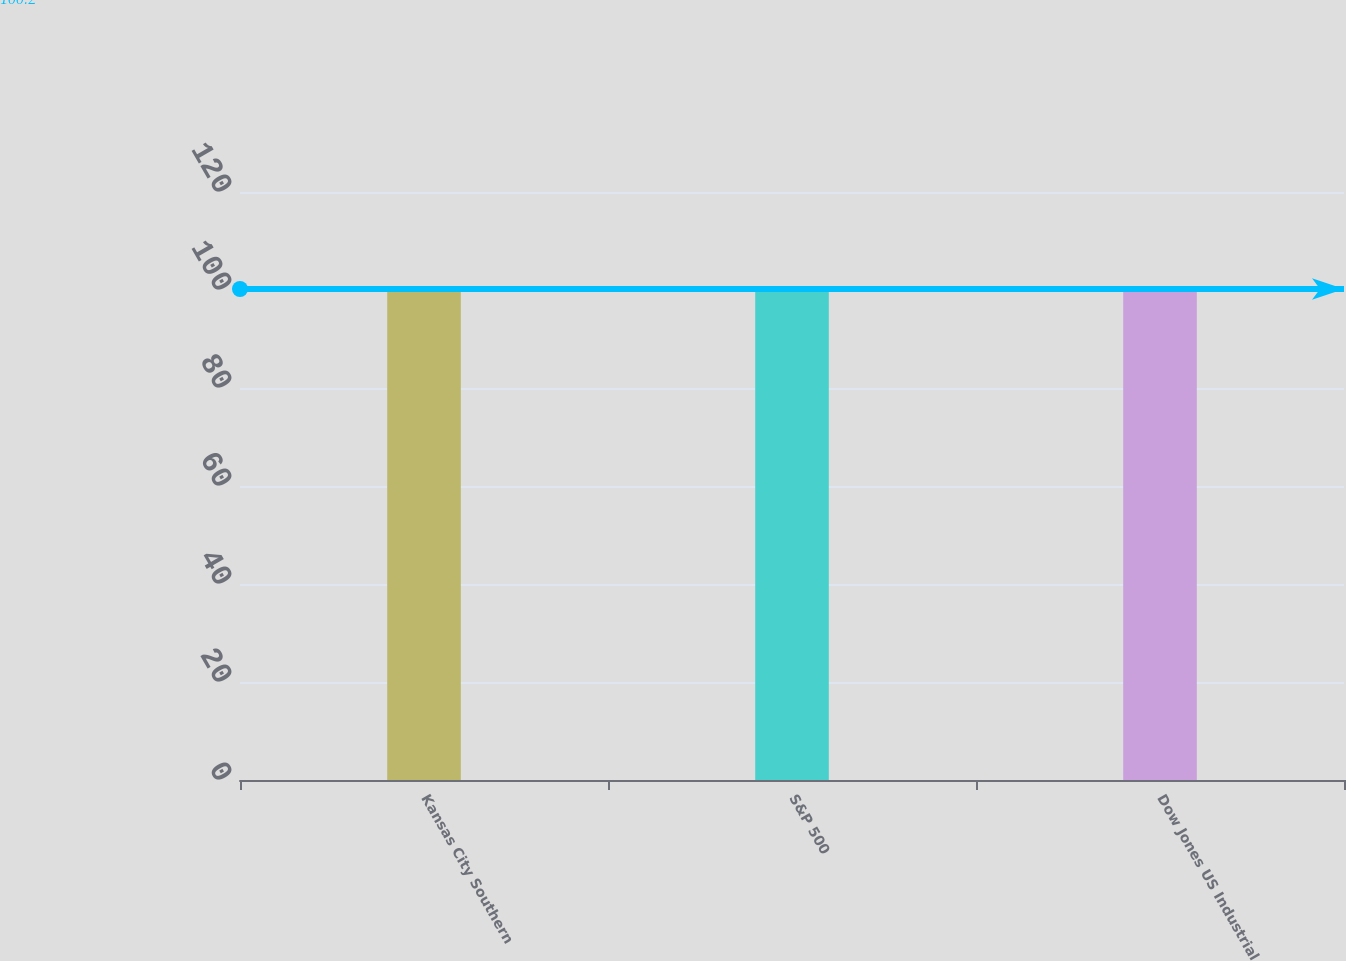Convert chart. <chart><loc_0><loc_0><loc_500><loc_500><bar_chart><fcel>Kansas City Southern<fcel>S&P 500<fcel>Dow Jones US Industrial<nl><fcel>100<fcel>100.1<fcel>100.2<nl></chart> 